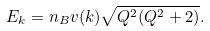Convert formula to latex. <formula><loc_0><loc_0><loc_500><loc_500>E _ { k } = n _ { B } v ( { k } ) \sqrt { Q ^ { 2 } ( Q ^ { 2 } + 2 ) } .</formula> 